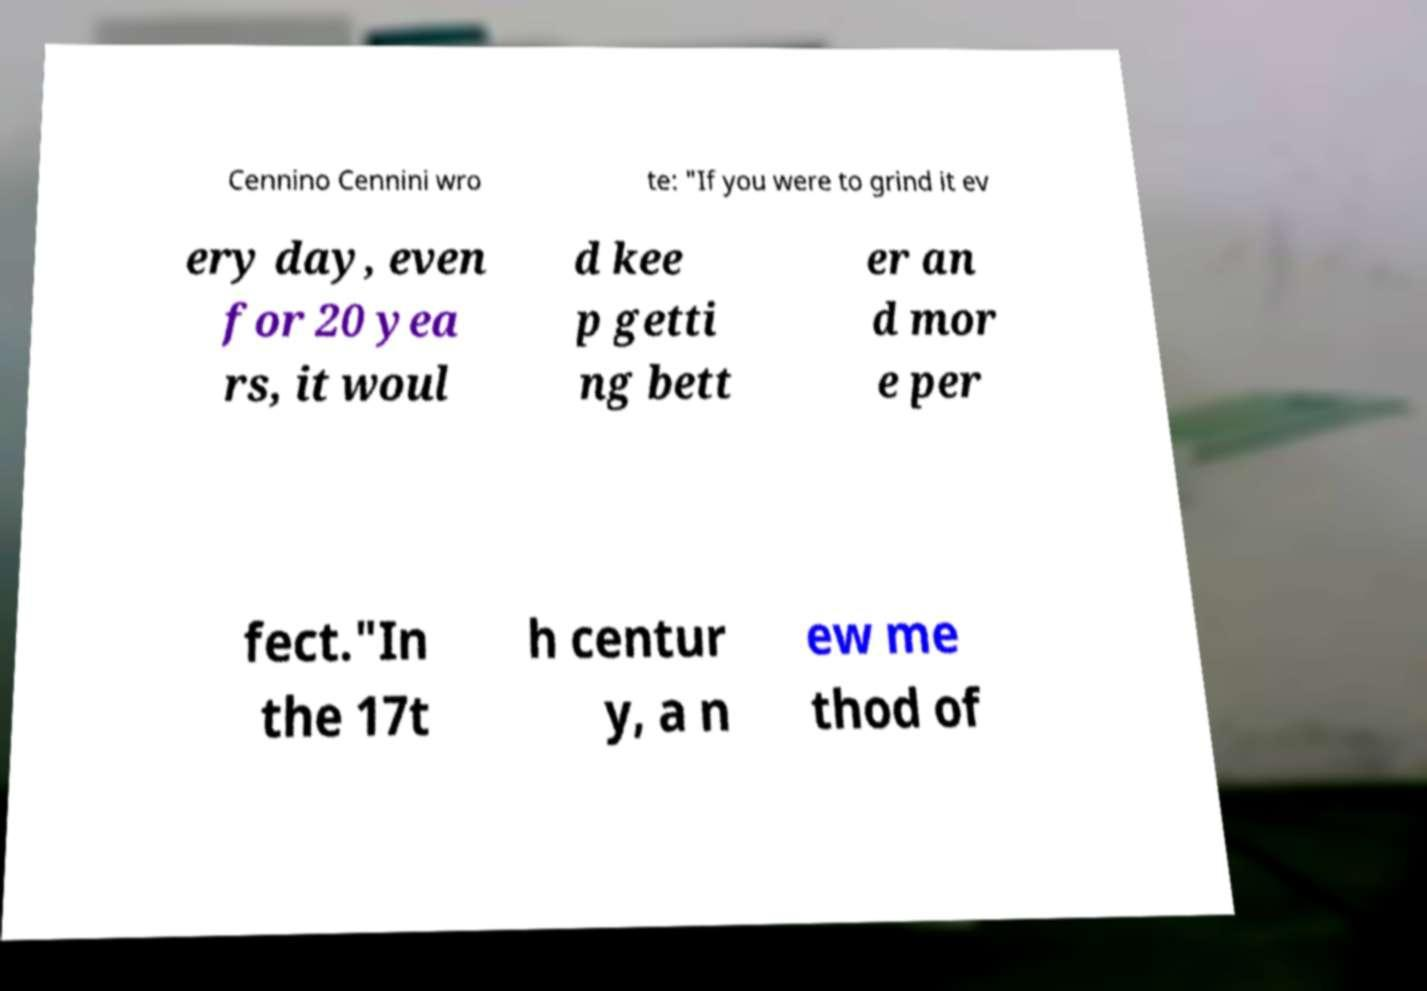Could you extract and type out the text from this image? Cennino Cennini wro te: "If you were to grind it ev ery day, even for 20 yea rs, it woul d kee p getti ng bett er an d mor e per fect."In the 17t h centur y, a n ew me thod of 